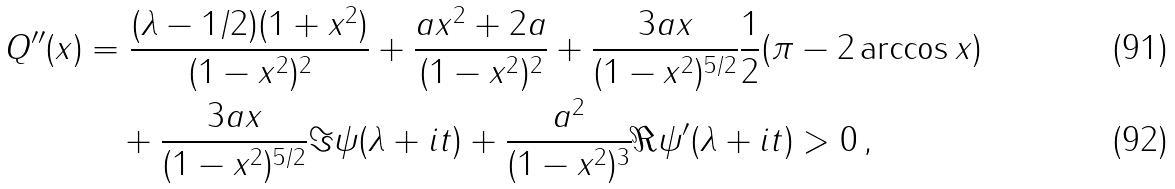Convert formula to latex. <formula><loc_0><loc_0><loc_500><loc_500>Q ^ { \prime \prime } ( x ) & = \frac { ( \lambda - 1 / 2 ) ( 1 + x ^ { 2 } ) } { ( 1 - x ^ { 2 } ) ^ { 2 } } + \frac { a x ^ { 2 } + 2 a } { ( 1 - x ^ { 2 } ) ^ { 2 } } + \frac { 3 a x } { ( 1 - x ^ { 2 } ) ^ { 5 / 2 } } \frac { 1 } { 2 } ( \pi - 2 \arccos x ) \\ & \quad + \frac { 3 a x } { ( 1 - x ^ { 2 } ) ^ { 5 / 2 } } \Im \psi ( \lambda + i t ) + \frac { a ^ { 2 } } { ( 1 - x ^ { 2 } ) ^ { 3 } } \Re \psi ^ { \prime } ( \lambda + i t ) > 0 \, ,</formula> 